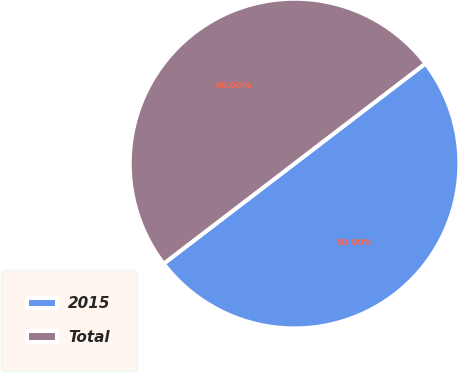<chart> <loc_0><loc_0><loc_500><loc_500><pie_chart><fcel>2015<fcel>Total<nl><fcel>50.0%<fcel>50.0%<nl></chart> 